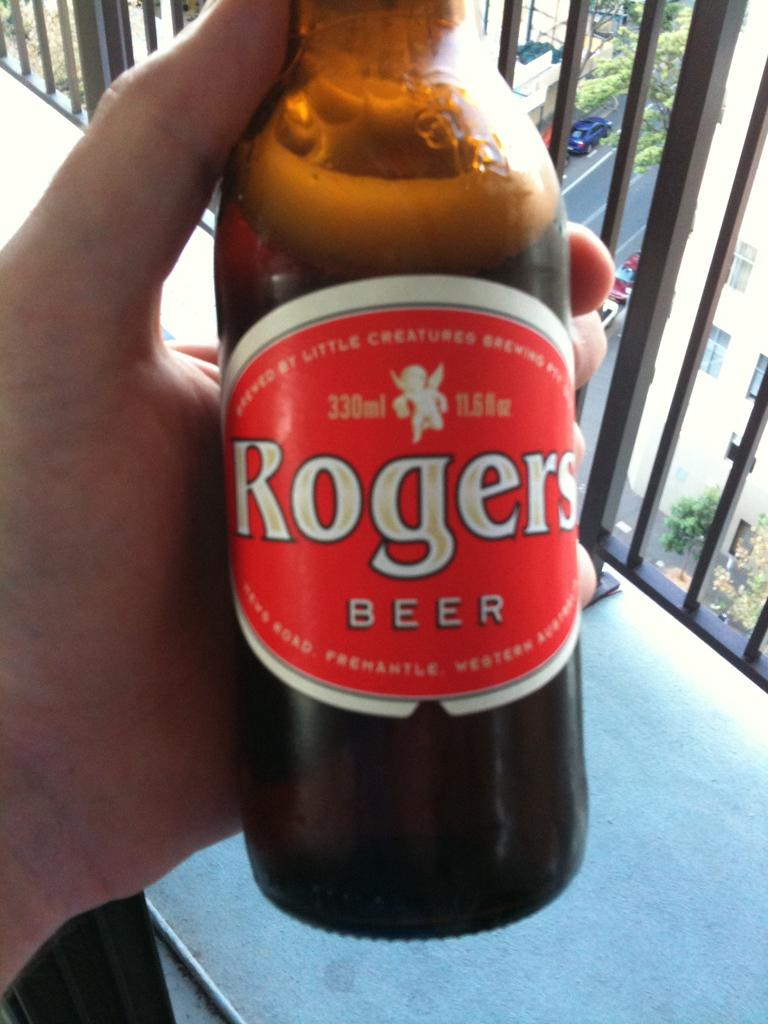Provide a one-sentence caption for the provided image. Rogers beer bottle being held by hand to take a photo. 